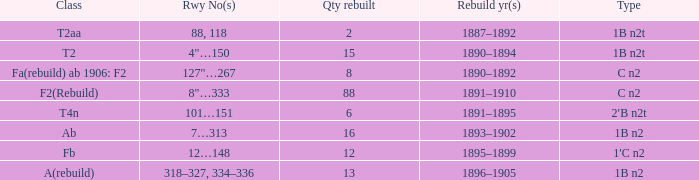What is the type if quantity rebuilt is more than 2 and the railway number is 4"…150? 1B n2t. 